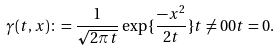Convert formula to latex. <formula><loc_0><loc_0><loc_500><loc_500>\gamma ( t , x ) \colon = \frac { 1 } { \sqrt { 2 \pi t } } \exp { \{ \frac { - x ^ { 2 } } { 2 t } \} } t \neq 0 0 t = 0 .</formula> 